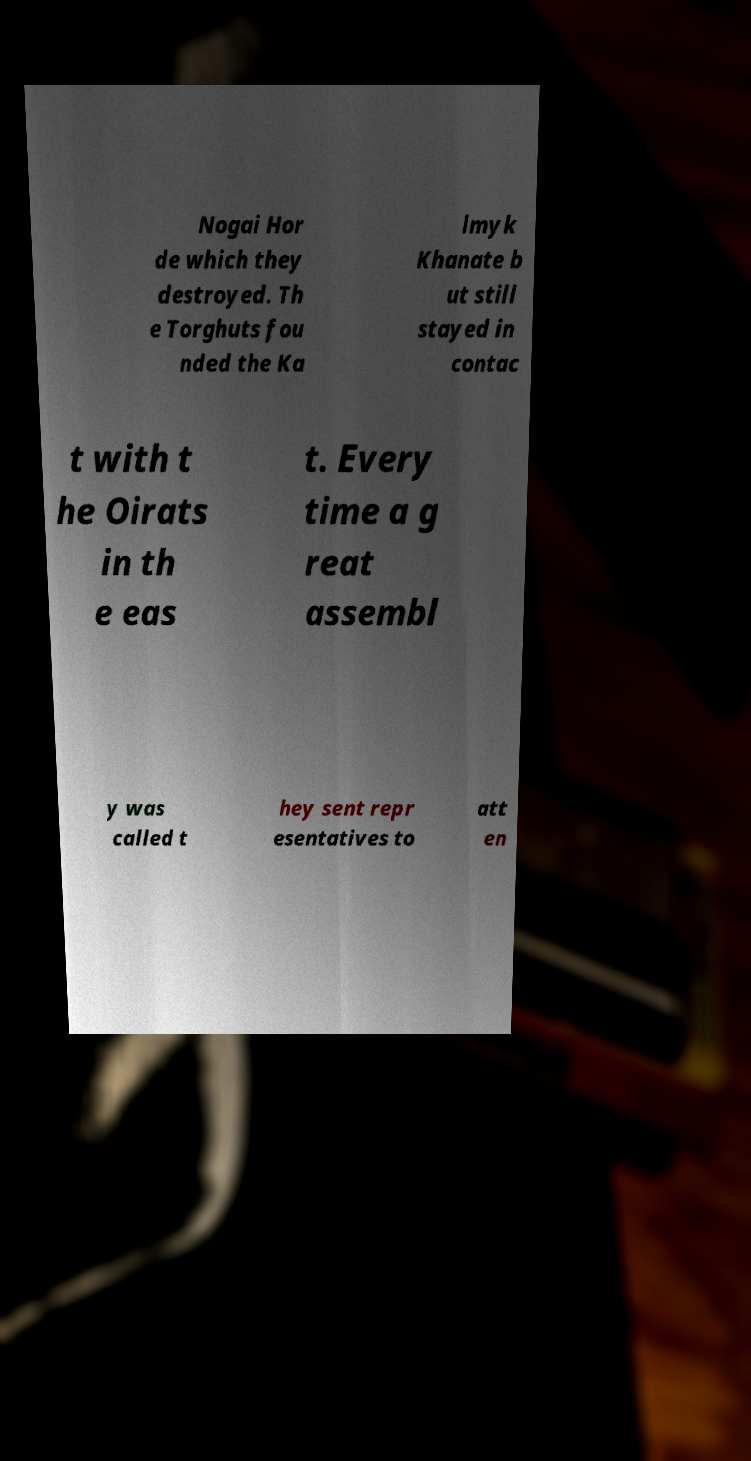For documentation purposes, I need the text within this image transcribed. Could you provide that? Nogai Hor de which they destroyed. Th e Torghuts fou nded the Ka lmyk Khanate b ut still stayed in contac t with t he Oirats in th e eas t. Every time a g reat assembl y was called t hey sent repr esentatives to att en 